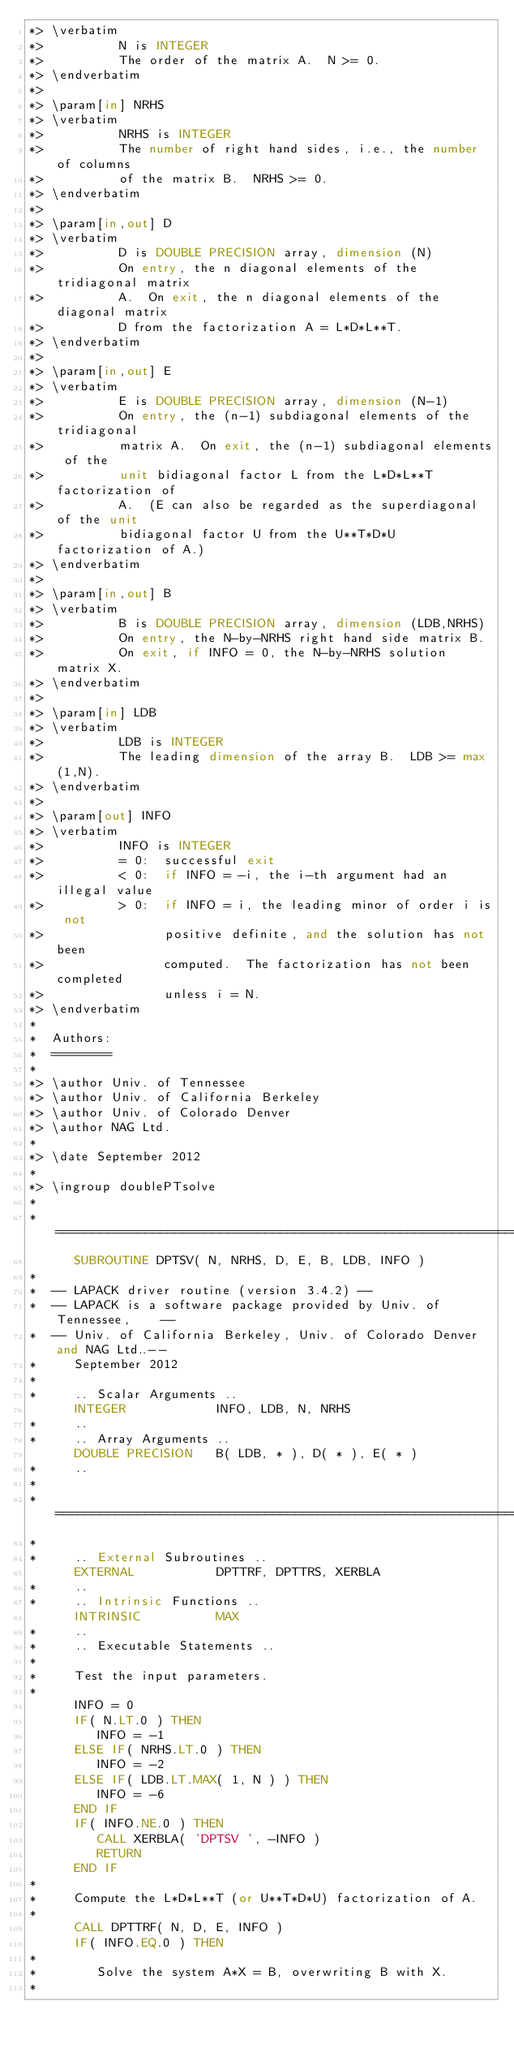<code> <loc_0><loc_0><loc_500><loc_500><_FORTRAN_>*> \verbatim
*>          N is INTEGER
*>          The order of the matrix A.  N >= 0.
*> \endverbatim
*>
*> \param[in] NRHS
*> \verbatim
*>          NRHS is INTEGER
*>          The number of right hand sides, i.e., the number of columns
*>          of the matrix B.  NRHS >= 0.
*> \endverbatim
*>
*> \param[in,out] D
*> \verbatim
*>          D is DOUBLE PRECISION array, dimension (N)
*>          On entry, the n diagonal elements of the tridiagonal matrix
*>          A.  On exit, the n diagonal elements of the diagonal matrix
*>          D from the factorization A = L*D*L**T.
*> \endverbatim
*>
*> \param[in,out] E
*> \verbatim
*>          E is DOUBLE PRECISION array, dimension (N-1)
*>          On entry, the (n-1) subdiagonal elements of the tridiagonal
*>          matrix A.  On exit, the (n-1) subdiagonal elements of the
*>          unit bidiagonal factor L from the L*D*L**T factorization of
*>          A.  (E can also be regarded as the superdiagonal of the unit
*>          bidiagonal factor U from the U**T*D*U factorization of A.)
*> \endverbatim
*>
*> \param[in,out] B
*> \verbatim
*>          B is DOUBLE PRECISION array, dimension (LDB,NRHS)
*>          On entry, the N-by-NRHS right hand side matrix B.
*>          On exit, if INFO = 0, the N-by-NRHS solution matrix X.
*> \endverbatim
*>
*> \param[in] LDB
*> \verbatim
*>          LDB is INTEGER
*>          The leading dimension of the array B.  LDB >= max(1,N).
*> \endverbatim
*>
*> \param[out] INFO
*> \verbatim
*>          INFO is INTEGER
*>          = 0:  successful exit
*>          < 0:  if INFO = -i, the i-th argument had an illegal value
*>          > 0:  if INFO = i, the leading minor of order i is not
*>                positive definite, and the solution has not been
*>                computed.  The factorization has not been completed
*>                unless i = N.
*> \endverbatim
*
*  Authors:
*  ========
*
*> \author Univ. of Tennessee 
*> \author Univ. of California Berkeley 
*> \author Univ. of Colorado Denver 
*> \author NAG Ltd. 
*
*> \date September 2012
*
*> \ingroup doublePTsolve
*
*  =====================================================================
      SUBROUTINE DPTSV( N, NRHS, D, E, B, LDB, INFO )
*
*  -- LAPACK driver routine (version 3.4.2) --
*  -- LAPACK is a software package provided by Univ. of Tennessee,    --
*  -- Univ. of California Berkeley, Univ. of Colorado Denver and NAG Ltd..--
*     September 2012
*
*     .. Scalar Arguments ..
      INTEGER            INFO, LDB, N, NRHS
*     ..
*     .. Array Arguments ..
      DOUBLE PRECISION   B( LDB, * ), D( * ), E( * )
*     ..
*
*  =====================================================================
*
*     .. External Subroutines ..
      EXTERNAL           DPTTRF, DPTTRS, XERBLA
*     ..
*     .. Intrinsic Functions ..
      INTRINSIC          MAX
*     ..
*     .. Executable Statements ..
*
*     Test the input parameters.
*
      INFO = 0
      IF( N.LT.0 ) THEN
         INFO = -1
      ELSE IF( NRHS.LT.0 ) THEN
         INFO = -2
      ELSE IF( LDB.LT.MAX( 1, N ) ) THEN
         INFO = -6
      END IF
      IF( INFO.NE.0 ) THEN
         CALL XERBLA( 'DPTSV ', -INFO )
         RETURN
      END IF
*
*     Compute the L*D*L**T (or U**T*D*U) factorization of A.
*
      CALL DPTTRF( N, D, E, INFO )
      IF( INFO.EQ.0 ) THEN
*
*        Solve the system A*X = B, overwriting B with X.
*</code> 